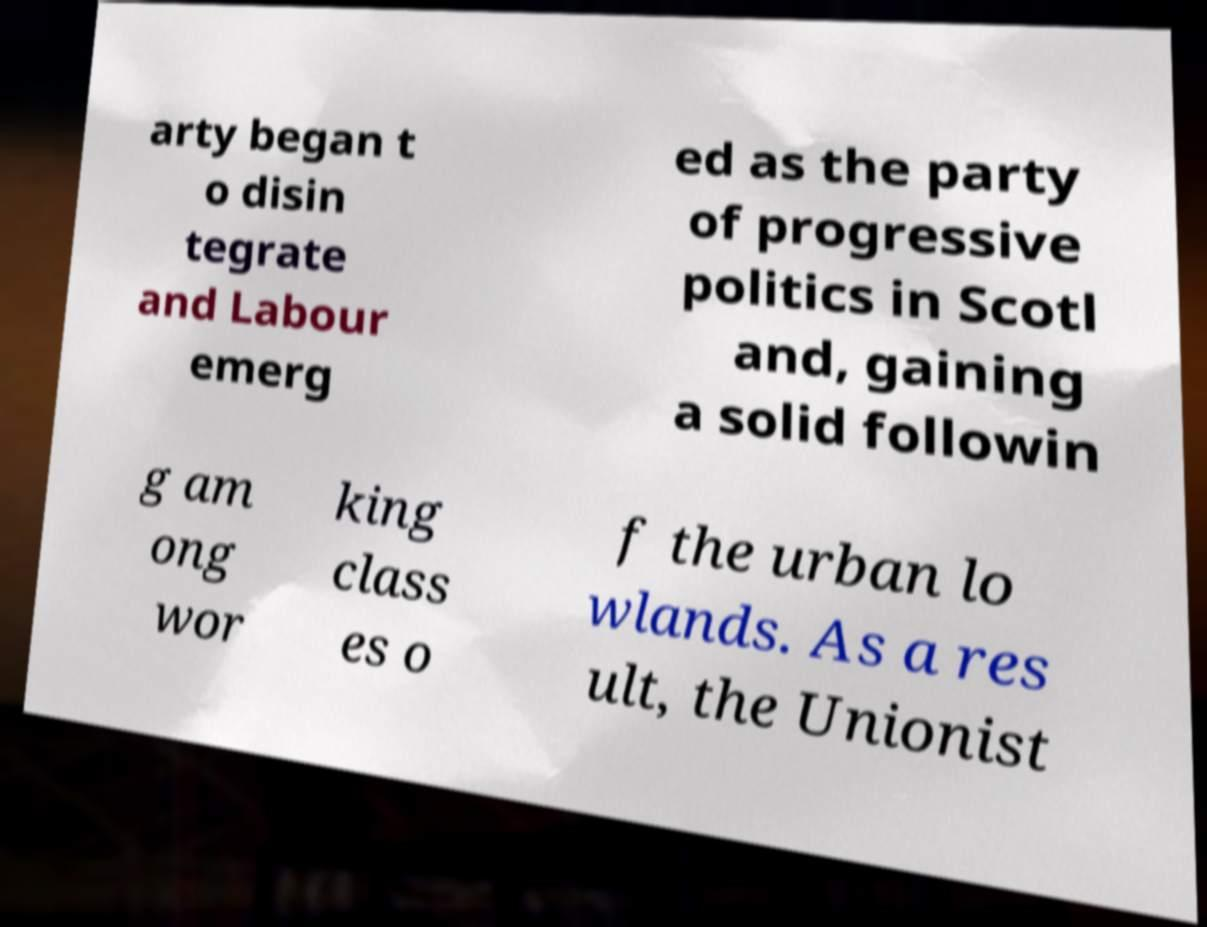I need the written content from this picture converted into text. Can you do that? arty began t o disin tegrate and Labour emerg ed as the party of progressive politics in Scotl and, gaining a solid followin g am ong wor king class es o f the urban lo wlands. As a res ult, the Unionist 